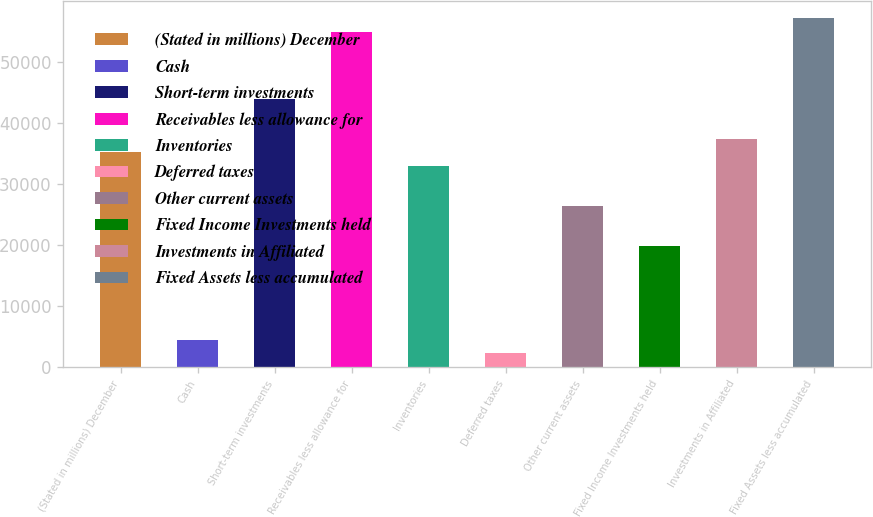Convert chart. <chart><loc_0><loc_0><loc_500><loc_500><bar_chart><fcel>(Stated in millions) December<fcel>Cash<fcel>Short-term investments<fcel>Receivables less allowance for<fcel>Inventories<fcel>Deferred taxes<fcel>Other current assets<fcel>Fixed Income Investments held<fcel>Investments in Affiliated<fcel>Fixed Assets less accumulated<nl><fcel>35165<fcel>4491<fcel>43929<fcel>54884<fcel>32974<fcel>2300<fcel>26401<fcel>19828<fcel>37356<fcel>57075<nl></chart> 